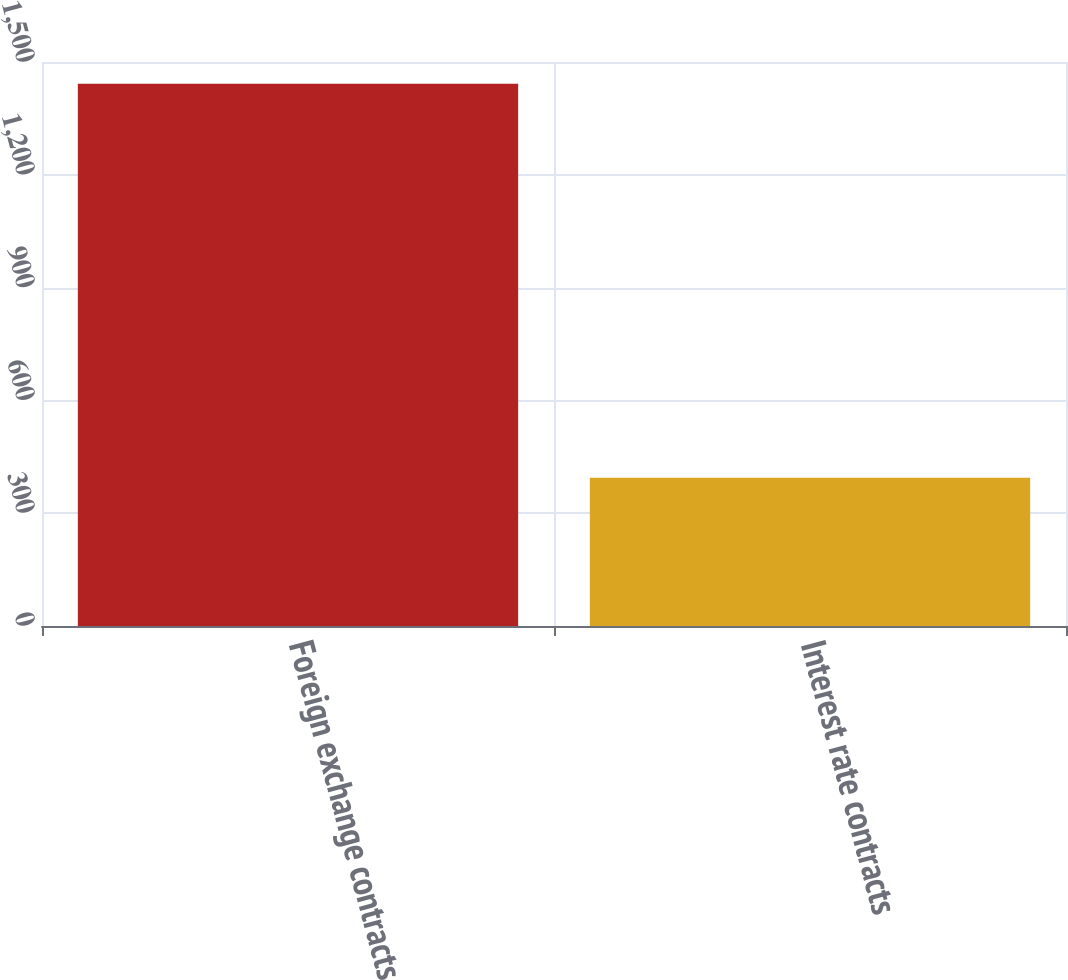Convert chart to OTSL. <chart><loc_0><loc_0><loc_500><loc_500><bar_chart><fcel>Foreign exchange contracts<fcel>Interest rate contracts<nl><fcel>1442<fcel>394<nl></chart> 